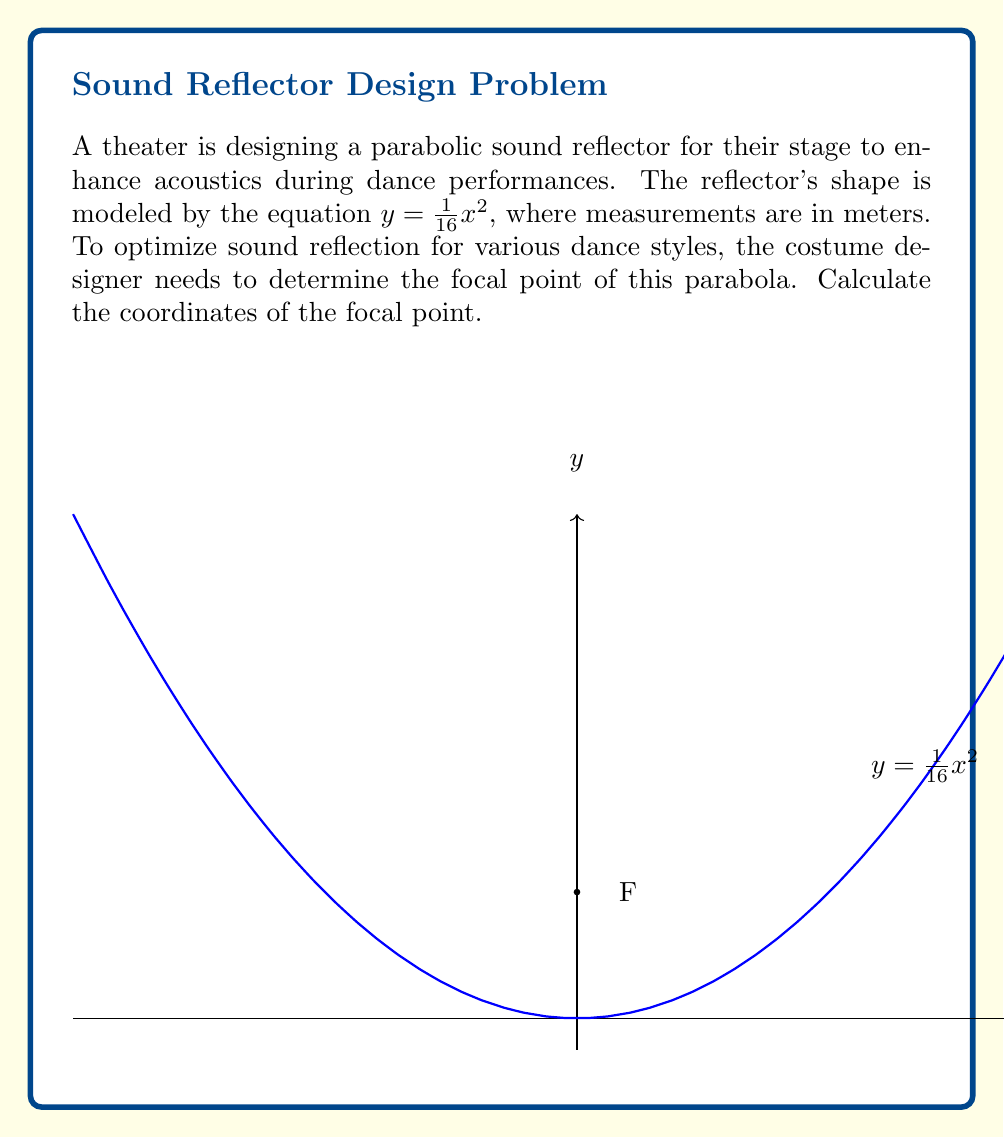Provide a solution to this math problem. Let's approach this step-by-step:

1) The general form of a parabola with vertex at the origin is:
   $y = ax^2$

2) In our case, $a = \frac{1}{16}$

3) For a parabola in this form, the focal point is located at $(0, \frac{1}{4a})$

4) Substituting our value of $a$:
   $y = \frac{1}{4a} = \frac{1}{4(\frac{1}{16})} = \frac{1}{4} \cdot 16 = 4$

5) Therefore, the focal point is at $(0, 4)$

This focal point is crucial for the costume designer to understand, as it affects how sound will be reflected during different dance performances. The reflector will concentrate sound waves at this point, which can influence decisions about costume materials and designs to optimize acoustics for various dance styles.
Answer: $(0, 4)$ 